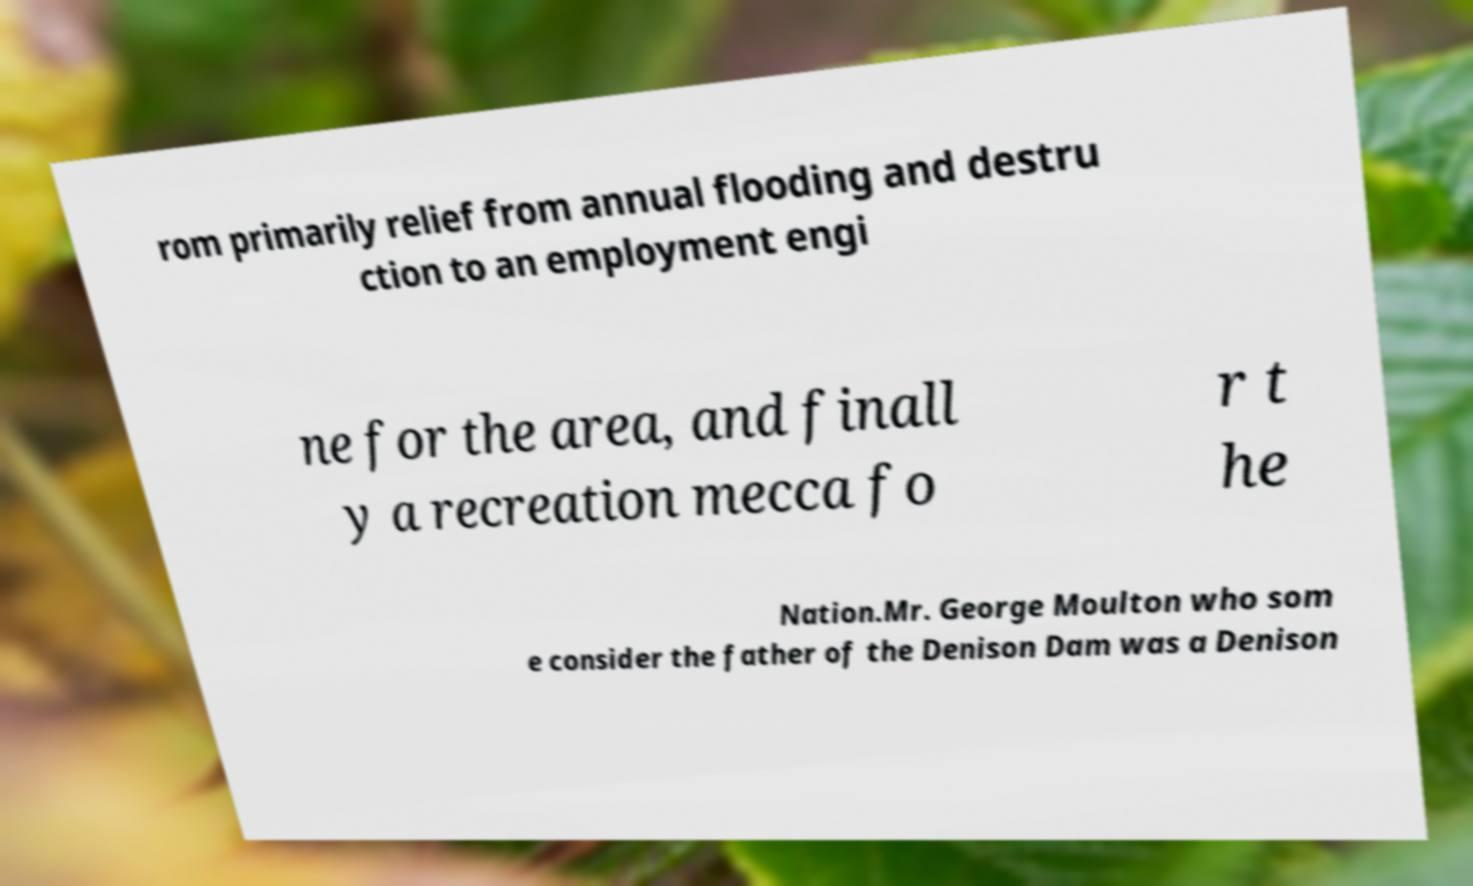Can you accurately transcribe the text from the provided image for me? rom primarily relief from annual flooding and destru ction to an employment engi ne for the area, and finall y a recreation mecca fo r t he Nation.Mr. George Moulton who som e consider the father of the Denison Dam was a Denison 